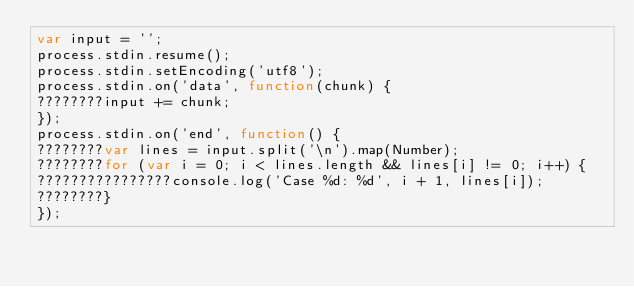<code> <loc_0><loc_0><loc_500><loc_500><_JavaScript_>var input = '';
process.stdin.resume();
process.stdin.setEncoding('utf8');
process.stdin.on('data', function(chunk) {
????????input += chunk;
});
process.stdin.on('end', function() {
????????var lines = input.split('\n').map(Number);
????????for (var i = 0; i < lines.length && lines[i] != 0; i++) {
????????????????console.log('Case %d: %d', i + 1, lines[i]);
????????}
});</code> 